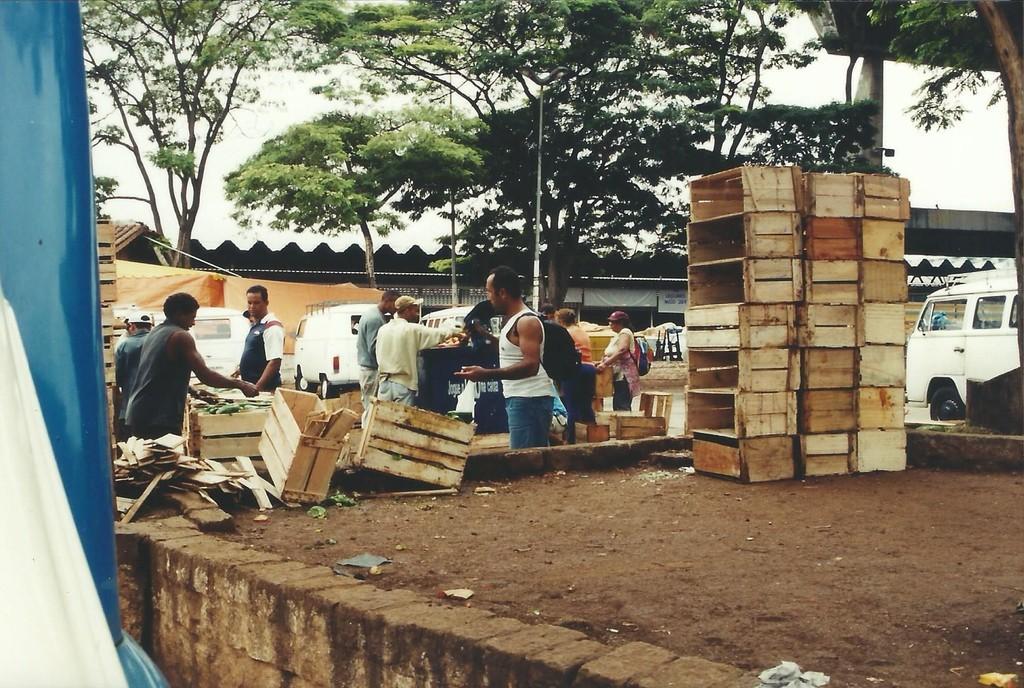Please provide a concise description of this image. In this image there are some people who are standing and some of them are holding some bags and some of them are wearing bags. At the bottom there is sand and some wooden boxes, in the background there are some houses, trees and some vehicles. On the left side there are some curtains. 